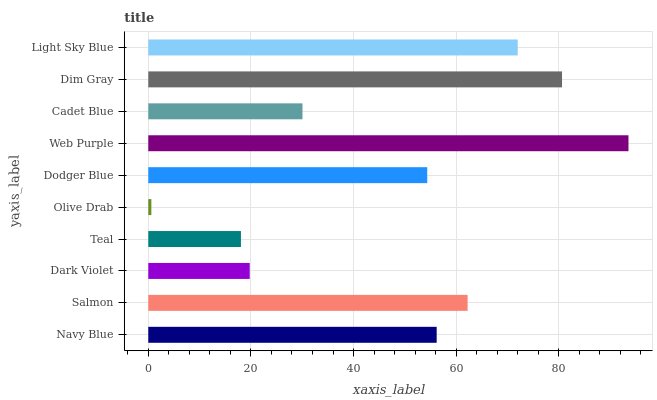Is Olive Drab the minimum?
Answer yes or no. Yes. Is Web Purple the maximum?
Answer yes or no. Yes. Is Salmon the minimum?
Answer yes or no. No. Is Salmon the maximum?
Answer yes or no. No. Is Salmon greater than Navy Blue?
Answer yes or no. Yes. Is Navy Blue less than Salmon?
Answer yes or no. Yes. Is Navy Blue greater than Salmon?
Answer yes or no. No. Is Salmon less than Navy Blue?
Answer yes or no. No. Is Navy Blue the high median?
Answer yes or no. Yes. Is Dodger Blue the low median?
Answer yes or no. Yes. Is Olive Drab the high median?
Answer yes or no. No. Is Salmon the low median?
Answer yes or no. No. 